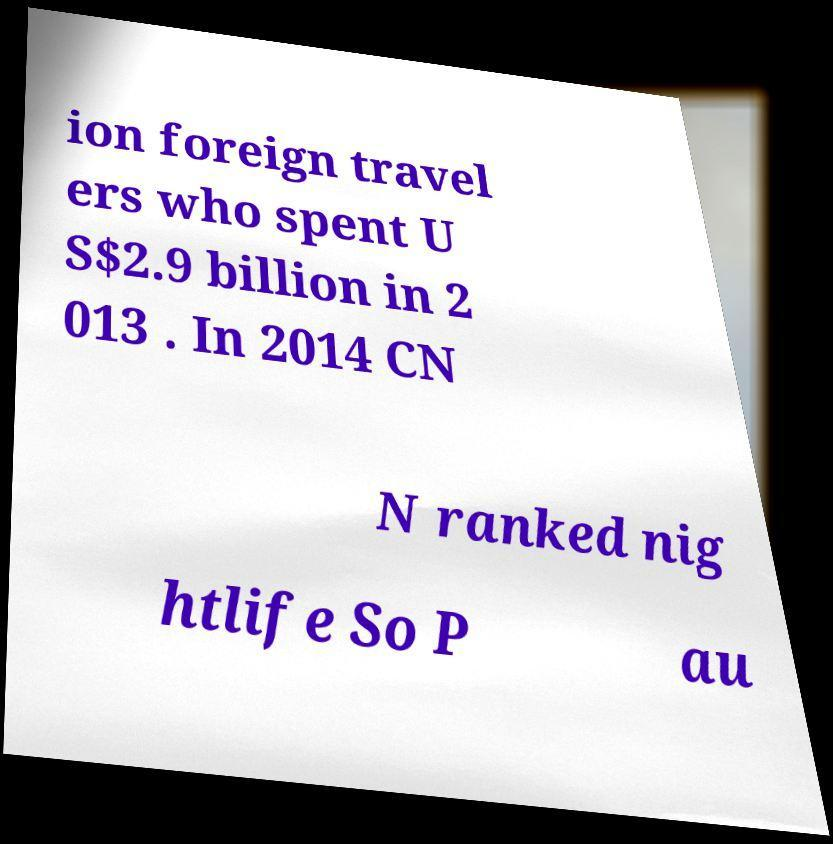Can you accurately transcribe the text from the provided image for me? ion foreign travel ers who spent U S$2.9 billion in 2 013 . In 2014 CN N ranked nig htlife So P au 